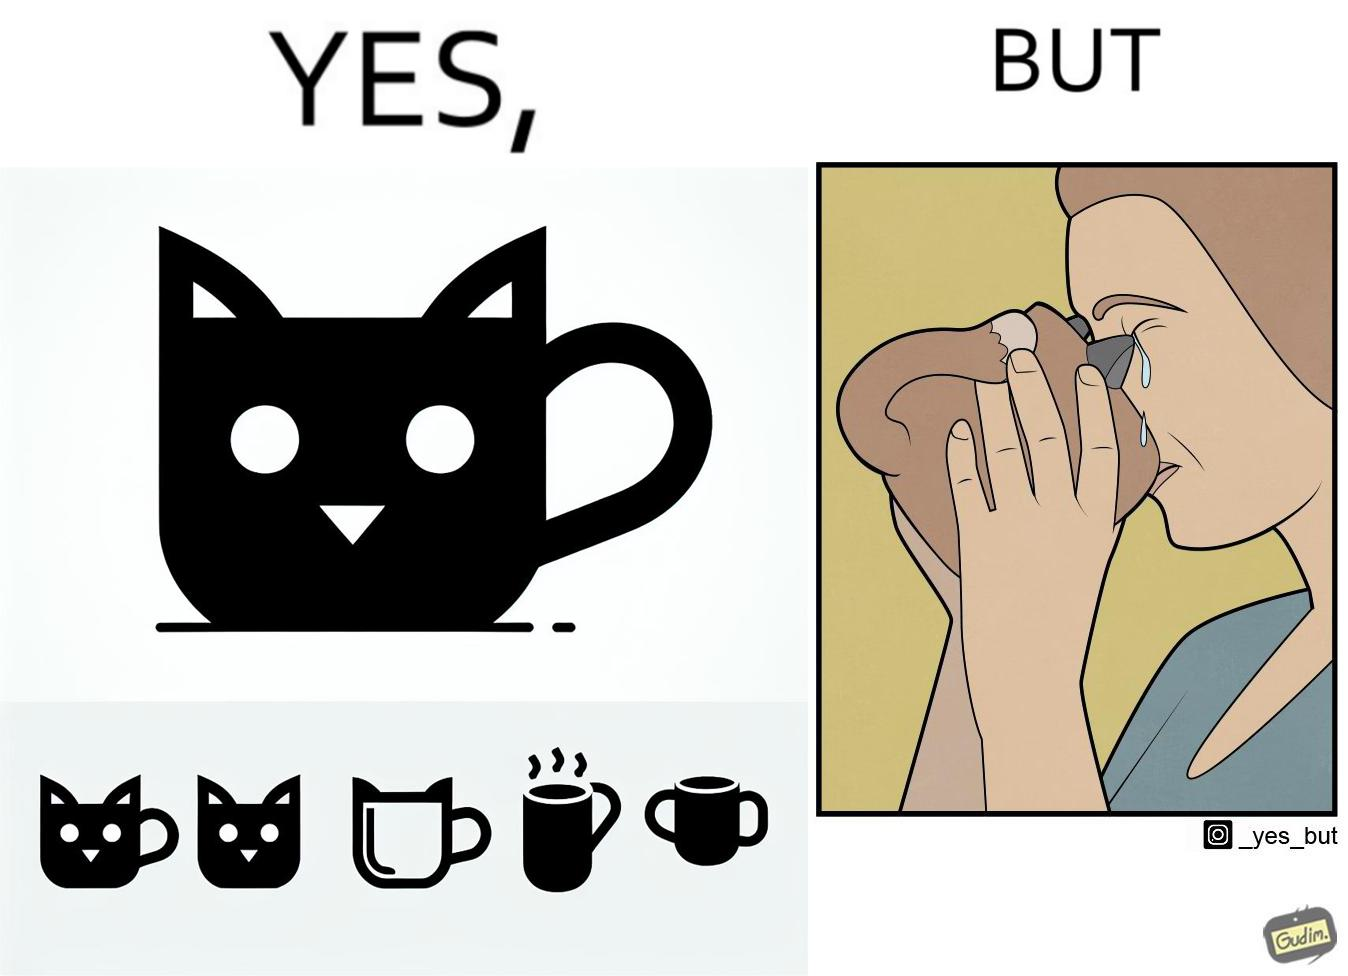Describe what you see in this image. The irony in the image is that the mug is supposedly cute and quirky but it is completely impractical as a mug as it will hurt its user. 